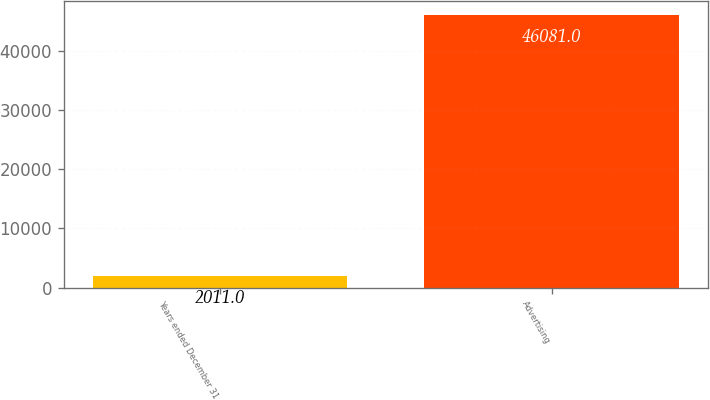Convert chart. <chart><loc_0><loc_0><loc_500><loc_500><bar_chart><fcel>Years ended December 31<fcel>Advertising<nl><fcel>2011<fcel>46081<nl></chart> 